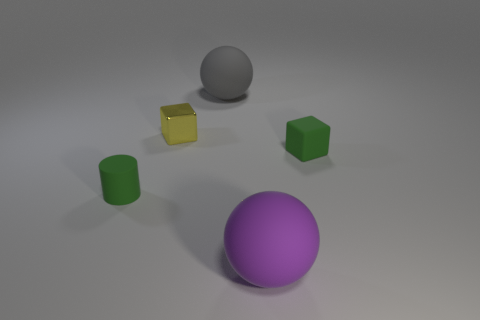Add 3 purple balls. How many objects exist? 8 Add 1 large matte things. How many large matte things are left? 3 Add 2 rubber things. How many rubber things exist? 6 Subtract 0 blue blocks. How many objects are left? 5 Subtract all cylinders. How many objects are left? 4 Subtract all green spheres. Subtract all blue cylinders. How many spheres are left? 2 Subtract all big gray things. Subtract all large balls. How many objects are left? 2 